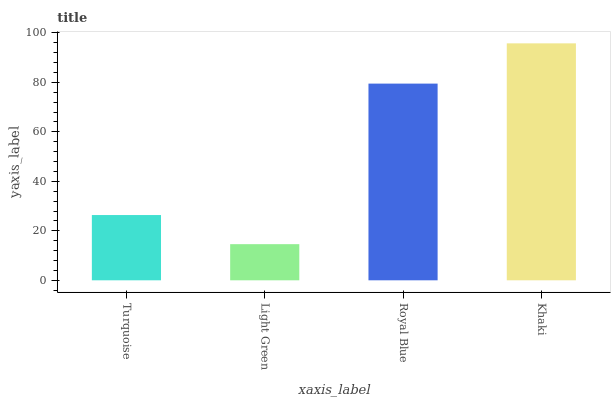Is Royal Blue the minimum?
Answer yes or no. No. Is Royal Blue the maximum?
Answer yes or no. No. Is Royal Blue greater than Light Green?
Answer yes or no. Yes. Is Light Green less than Royal Blue?
Answer yes or no. Yes. Is Light Green greater than Royal Blue?
Answer yes or no. No. Is Royal Blue less than Light Green?
Answer yes or no. No. Is Royal Blue the high median?
Answer yes or no. Yes. Is Turquoise the low median?
Answer yes or no. Yes. Is Turquoise the high median?
Answer yes or no. No. Is Royal Blue the low median?
Answer yes or no. No. 